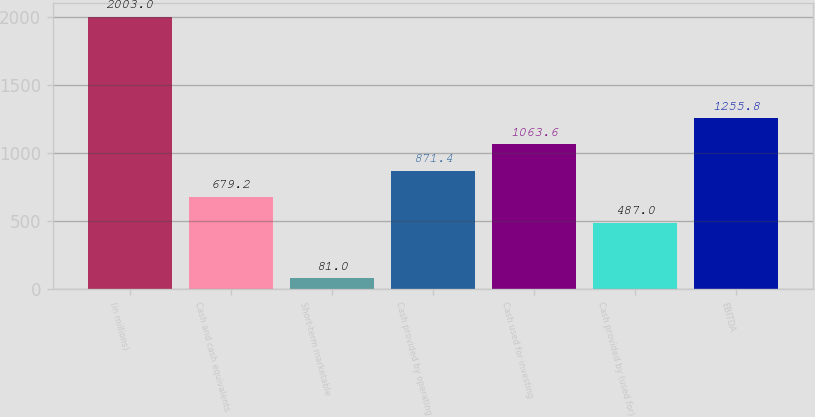Convert chart to OTSL. <chart><loc_0><loc_0><loc_500><loc_500><bar_chart><fcel>(in millions)<fcel>Cash and cash equivalents<fcel>Short-term marketable<fcel>Cash provided by operating<fcel>Cash used for investing<fcel>Cash provided by (used for)<fcel>EBITDA<nl><fcel>2003<fcel>679.2<fcel>81<fcel>871.4<fcel>1063.6<fcel>487<fcel>1255.8<nl></chart> 